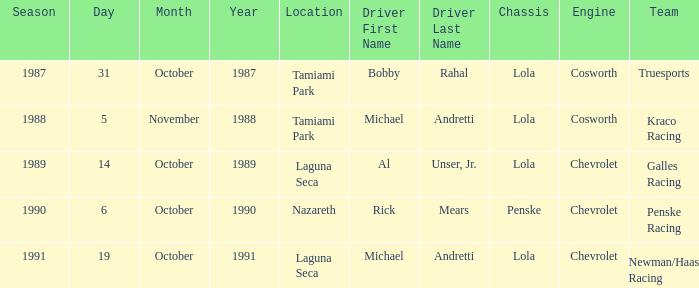What engine does Galles Racing use? Chevrolet. 